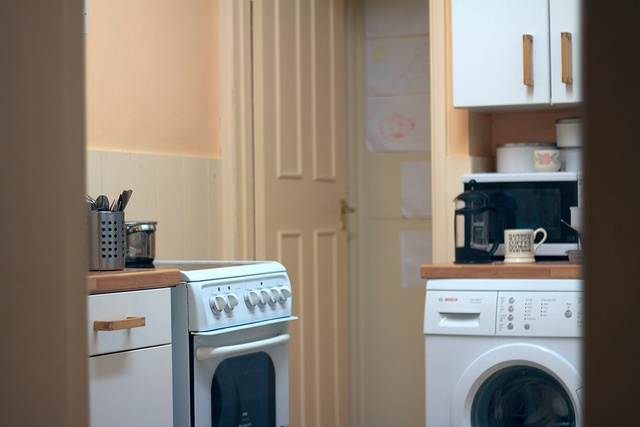Describe the objects in this image and their specific colors. I can see oven in gray, black, darkgray, and lightblue tones, oven in gray, black, darkgray, and lightgray tones, microwave in gray, black, lavender, darkgray, and lightgray tones, cup in gray, darkgray, tan, and lightgray tones, and cup in gray and darkgray tones in this image. 